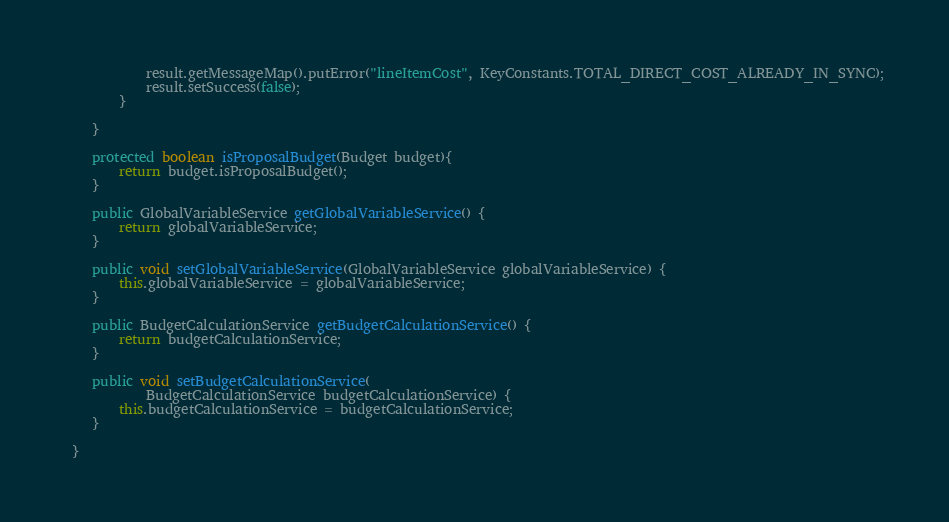Convert code to text. <code><loc_0><loc_0><loc_500><loc_500><_Java_>        	result.getMessageMap().putError("lineItemCost", KeyConstants.TOTAL_DIRECT_COST_ALREADY_IN_SYNC);
            result.setSuccess(false);
        }
    	
    }
    
    protected boolean isProposalBudget(Budget budget){
        return budget.isProposalBudget();
    }
    
	public GlobalVariableService getGlobalVariableService() {
		return globalVariableService;
	}

	public void setGlobalVariableService(GlobalVariableService globalVariableService) {
		this.globalVariableService = globalVariableService;
	}

	public BudgetCalculationService getBudgetCalculationService() {
		return budgetCalculationService;
	}

	public void setBudgetCalculationService(
			BudgetCalculationService budgetCalculationService) {
		this.budgetCalculationService = budgetCalculationService;
	}
	
 }
</code> 